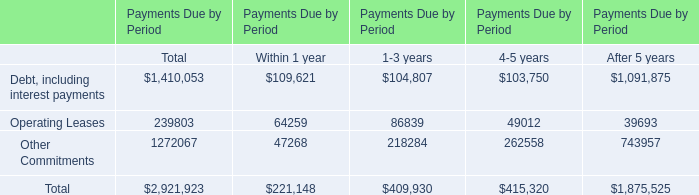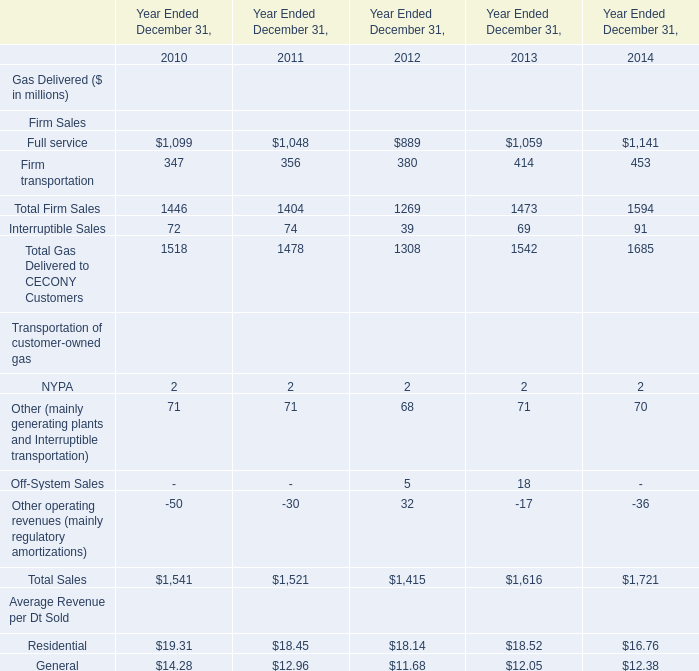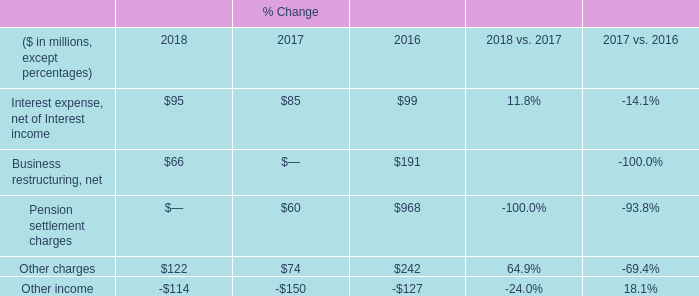What was the total amount of NYPA,Other (mainly generating plants and Interruptible transportation), Off-System Sales and Other operating revenues (mainly regulatory amortizations) in in 2012？ (in million) 
Computations: (((2 + 68) + 5) + 32)
Answer: 107.0. 